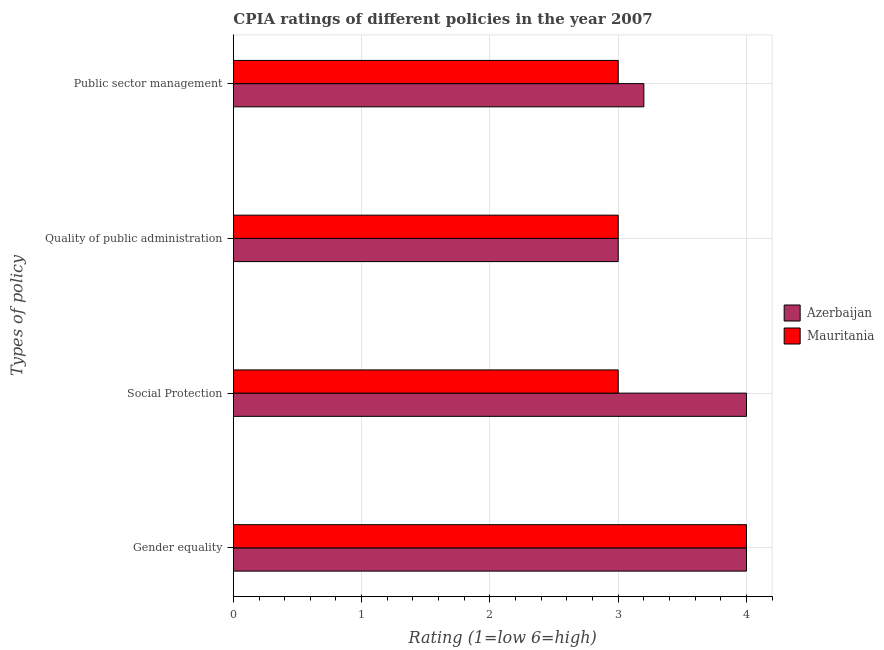How many groups of bars are there?
Make the answer very short. 4. Are the number of bars on each tick of the Y-axis equal?
Offer a terse response. Yes. How many bars are there on the 4th tick from the top?
Your response must be concise. 2. How many bars are there on the 4th tick from the bottom?
Your answer should be compact. 2. What is the label of the 1st group of bars from the top?
Provide a succinct answer. Public sector management. Across all countries, what is the maximum cpia rating of social protection?
Give a very brief answer. 4. In which country was the cpia rating of quality of public administration maximum?
Your answer should be very brief. Azerbaijan. In which country was the cpia rating of social protection minimum?
Your answer should be compact. Mauritania. What is the total cpia rating of social protection in the graph?
Make the answer very short. 7. What is the difference between the cpia rating of social protection in Mauritania and that in Azerbaijan?
Keep it short and to the point. -1. What is the difference between the cpia rating of social protection in Azerbaijan and the cpia rating of public sector management in Mauritania?
Make the answer very short. 1. What is the ratio of the cpia rating of public sector management in Mauritania to that in Azerbaijan?
Provide a succinct answer. 0.94. What is the difference between the highest and the second highest cpia rating of public sector management?
Your answer should be compact. 0.2. In how many countries, is the cpia rating of public sector management greater than the average cpia rating of public sector management taken over all countries?
Your response must be concise. 1. Is the sum of the cpia rating of gender equality in Azerbaijan and Mauritania greater than the maximum cpia rating of quality of public administration across all countries?
Make the answer very short. Yes. Is it the case that in every country, the sum of the cpia rating of public sector management and cpia rating of gender equality is greater than the sum of cpia rating of quality of public administration and cpia rating of social protection?
Provide a short and direct response. Yes. What does the 1st bar from the top in Quality of public administration represents?
Offer a very short reply. Mauritania. What does the 2nd bar from the bottom in Quality of public administration represents?
Your answer should be very brief. Mauritania. Is it the case that in every country, the sum of the cpia rating of gender equality and cpia rating of social protection is greater than the cpia rating of quality of public administration?
Offer a terse response. Yes. What is the difference between two consecutive major ticks on the X-axis?
Offer a terse response. 1. Does the graph contain any zero values?
Provide a short and direct response. No. Where does the legend appear in the graph?
Offer a very short reply. Center right. How many legend labels are there?
Provide a short and direct response. 2. How are the legend labels stacked?
Offer a terse response. Vertical. What is the title of the graph?
Offer a terse response. CPIA ratings of different policies in the year 2007. Does "Virgin Islands" appear as one of the legend labels in the graph?
Ensure brevity in your answer.  No. What is the label or title of the Y-axis?
Your response must be concise. Types of policy. What is the Rating (1=low 6=high) in Mauritania in Gender equality?
Your answer should be very brief. 4. What is the Rating (1=low 6=high) of Azerbaijan in Social Protection?
Your answer should be compact. 4. What is the Rating (1=low 6=high) of Mauritania in Social Protection?
Make the answer very short. 3. What is the Rating (1=low 6=high) in Azerbaijan in Quality of public administration?
Offer a terse response. 3. Across all Types of policy, what is the maximum Rating (1=low 6=high) in Azerbaijan?
Offer a terse response. 4. Across all Types of policy, what is the maximum Rating (1=low 6=high) in Mauritania?
Offer a terse response. 4. Across all Types of policy, what is the minimum Rating (1=low 6=high) in Azerbaijan?
Your answer should be very brief. 3. Across all Types of policy, what is the minimum Rating (1=low 6=high) of Mauritania?
Offer a very short reply. 3. What is the difference between the Rating (1=low 6=high) of Mauritania in Gender equality and that in Social Protection?
Offer a terse response. 1. What is the difference between the Rating (1=low 6=high) in Azerbaijan in Gender equality and that in Quality of public administration?
Your answer should be compact. 1. What is the difference between the Rating (1=low 6=high) of Mauritania in Gender equality and that in Quality of public administration?
Your answer should be very brief. 1. What is the difference between the Rating (1=low 6=high) in Mauritania in Gender equality and that in Public sector management?
Provide a short and direct response. 1. What is the difference between the Rating (1=low 6=high) of Azerbaijan in Social Protection and that in Quality of public administration?
Your response must be concise. 1. What is the difference between the Rating (1=low 6=high) of Azerbaijan in Social Protection and that in Public sector management?
Offer a very short reply. 0.8. What is the difference between the Rating (1=low 6=high) of Azerbaijan in Gender equality and the Rating (1=low 6=high) of Mauritania in Social Protection?
Your response must be concise. 1. What is the difference between the Rating (1=low 6=high) in Azerbaijan in Gender equality and the Rating (1=low 6=high) in Mauritania in Quality of public administration?
Your response must be concise. 1. What is the difference between the Rating (1=low 6=high) in Azerbaijan in Gender equality and the Rating (1=low 6=high) in Mauritania in Public sector management?
Provide a succinct answer. 1. What is the difference between the Rating (1=low 6=high) in Azerbaijan in Quality of public administration and the Rating (1=low 6=high) in Mauritania in Public sector management?
Your answer should be very brief. 0. What is the average Rating (1=low 6=high) of Azerbaijan per Types of policy?
Offer a very short reply. 3.55. What is the average Rating (1=low 6=high) in Mauritania per Types of policy?
Ensure brevity in your answer.  3.25. What is the difference between the Rating (1=low 6=high) of Azerbaijan and Rating (1=low 6=high) of Mauritania in Gender equality?
Your answer should be compact. 0. What is the difference between the Rating (1=low 6=high) in Azerbaijan and Rating (1=low 6=high) in Mauritania in Quality of public administration?
Provide a short and direct response. 0. What is the difference between the Rating (1=low 6=high) in Azerbaijan and Rating (1=low 6=high) in Mauritania in Public sector management?
Give a very brief answer. 0.2. What is the ratio of the Rating (1=low 6=high) in Mauritania in Gender equality to that in Social Protection?
Your answer should be compact. 1.33. What is the ratio of the Rating (1=low 6=high) in Mauritania in Gender equality to that in Public sector management?
Make the answer very short. 1.33. What is the ratio of the Rating (1=low 6=high) in Azerbaijan in Social Protection to that in Quality of public administration?
Make the answer very short. 1.33. What is the ratio of the Rating (1=low 6=high) in Azerbaijan in Social Protection to that in Public sector management?
Give a very brief answer. 1.25. What is the ratio of the Rating (1=low 6=high) in Mauritania in Social Protection to that in Public sector management?
Offer a terse response. 1. What is the ratio of the Rating (1=low 6=high) in Mauritania in Quality of public administration to that in Public sector management?
Your answer should be very brief. 1. What is the difference between the highest and the second highest Rating (1=low 6=high) of Azerbaijan?
Ensure brevity in your answer.  0. What is the difference between the highest and the second highest Rating (1=low 6=high) of Mauritania?
Offer a terse response. 1. What is the difference between the highest and the lowest Rating (1=low 6=high) in Mauritania?
Offer a terse response. 1. 